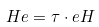<formula> <loc_0><loc_0><loc_500><loc_500>H e = \tau \cdot e H</formula> 